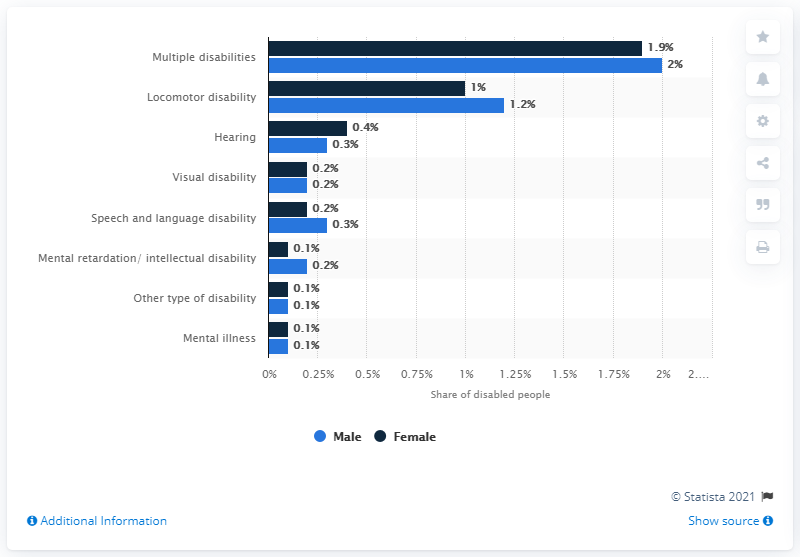Point out several critical features in this image. According to the data, approximately 1.9% of women in Tamil Nadu had multiple disabilities. 